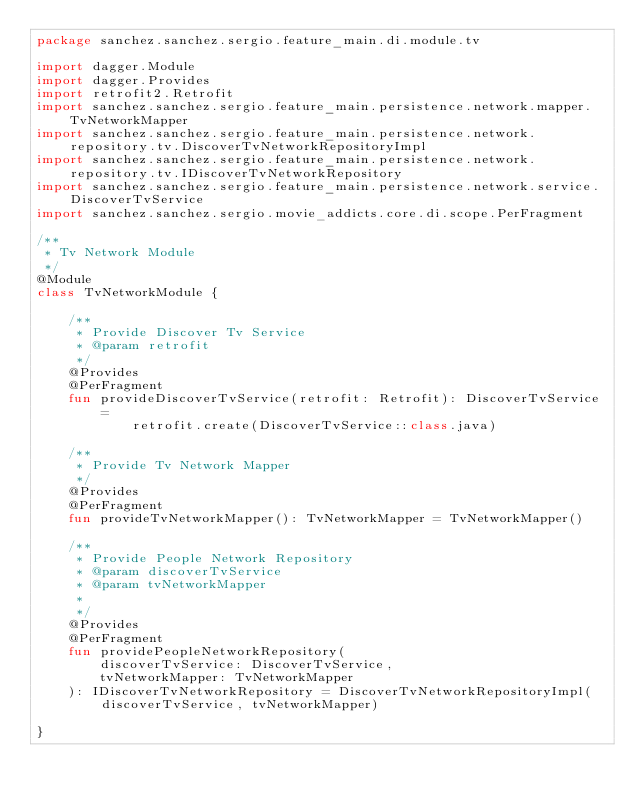Convert code to text. <code><loc_0><loc_0><loc_500><loc_500><_Kotlin_>package sanchez.sanchez.sergio.feature_main.di.module.tv

import dagger.Module
import dagger.Provides
import retrofit2.Retrofit
import sanchez.sanchez.sergio.feature_main.persistence.network.mapper.TvNetworkMapper
import sanchez.sanchez.sergio.feature_main.persistence.network.repository.tv.DiscoverTvNetworkRepositoryImpl
import sanchez.sanchez.sergio.feature_main.persistence.network.repository.tv.IDiscoverTvNetworkRepository
import sanchez.sanchez.sergio.feature_main.persistence.network.service.DiscoverTvService
import sanchez.sanchez.sergio.movie_addicts.core.di.scope.PerFragment

/**
 * Tv Network Module
 */
@Module
class TvNetworkModule {

    /**
     * Provide Discover Tv Service
     * @param retrofit
     */
    @Provides
    @PerFragment
    fun provideDiscoverTvService(retrofit: Retrofit): DiscoverTvService =
            retrofit.create(DiscoverTvService::class.java)

    /**
     * Provide Tv Network Mapper
     */
    @Provides
    @PerFragment
    fun provideTvNetworkMapper(): TvNetworkMapper = TvNetworkMapper()

    /**
     * Provide People Network Repository
     * @param discoverTvService
     * @param tvNetworkMapper
     *
     */
    @Provides
    @PerFragment
    fun providePeopleNetworkRepository(
        discoverTvService: DiscoverTvService,
        tvNetworkMapper: TvNetworkMapper
    ): IDiscoverTvNetworkRepository = DiscoverTvNetworkRepositoryImpl(discoverTvService, tvNetworkMapper)

}</code> 